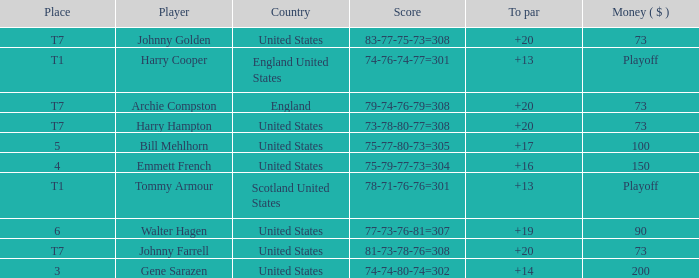What is the ranking when Archie Compston is the player and the money is $73? T7. 